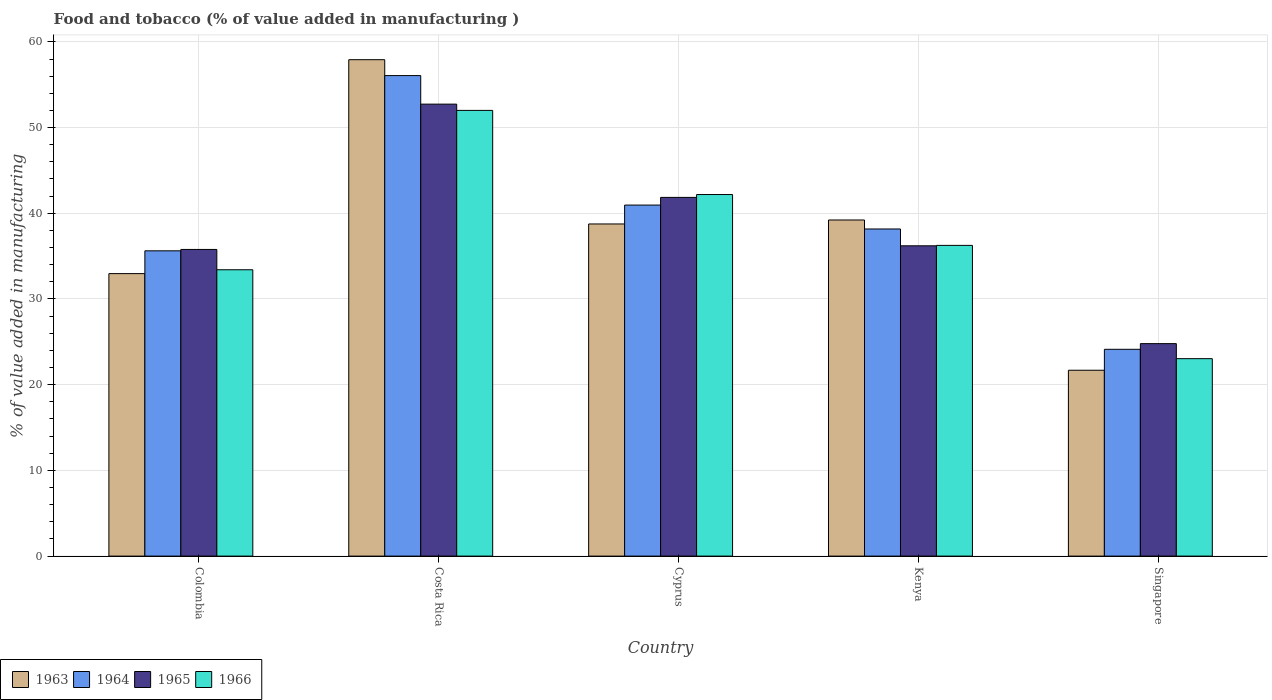How many different coloured bars are there?
Ensure brevity in your answer.  4. Are the number of bars per tick equal to the number of legend labels?
Your answer should be very brief. Yes. How many bars are there on the 5th tick from the left?
Your response must be concise. 4. How many bars are there on the 1st tick from the right?
Offer a terse response. 4. What is the label of the 3rd group of bars from the left?
Offer a terse response. Cyprus. What is the value added in manufacturing food and tobacco in 1963 in Singapore?
Provide a short and direct response. 21.69. Across all countries, what is the maximum value added in manufacturing food and tobacco in 1965?
Your response must be concise. 52.73. Across all countries, what is the minimum value added in manufacturing food and tobacco in 1964?
Your response must be concise. 24.13. In which country was the value added in manufacturing food and tobacco in 1963 maximum?
Ensure brevity in your answer.  Costa Rica. In which country was the value added in manufacturing food and tobacco in 1966 minimum?
Keep it short and to the point. Singapore. What is the total value added in manufacturing food and tobacco in 1965 in the graph?
Your answer should be very brief. 191.36. What is the difference between the value added in manufacturing food and tobacco in 1964 in Kenya and that in Singapore?
Your response must be concise. 14.04. What is the difference between the value added in manufacturing food and tobacco in 1963 in Singapore and the value added in manufacturing food and tobacco in 1966 in Costa Rica?
Provide a succinct answer. -30.32. What is the average value added in manufacturing food and tobacco in 1963 per country?
Ensure brevity in your answer.  38.11. What is the difference between the value added in manufacturing food and tobacco of/in 1965 and value added in manufacturing food and tobacco of/in 1963 in Colombia?
Offer a very short reply. 2.82. In how many countries, is the value added in manufacturing food and tobacco in 1964 greater than 48 %?
Offer a very short reply. 1. What is the ratio of the value added in manufacturing food and tobacco in 1965 in Cyprus to that in Kenya?
Offer a terse response. 1.16. What is the difference between the highest and the second highest value added in manufacturing food and tobacco in 1966?
Provide a short and direct response. -9.82. What is the difference between the highest and the lowest value added in manufacturing food and tobacco in 1964?
Offer a very short reply. 31.94. Is the sum of the value added in manufacturing food and tobacco in 1965 in Costa Rica and Singapore greater than the maximum value added in manufacturing food and tobacco in 1964 across all countries?
Keep it short and to the point. Yes. What does the 2nd bar from the left in Kenya represents?
Keep it short and to the point. 1964. What does the 1st bar from the right in Cyprus represents?
Offer a very short reply. 1966. How many bars are there?
Provide a succinct answer. 20. Are all the bars in the graph horizontal?
Offer a terse response. No. How many countries are there in the graph?
Make the answer very short. 5. Are the values on the major ticks of Y-axis written in scientific E-notation?
Provide a short and direct response. No. Does the graph contain any zero values?
Keep it short and to the point. No. Does the graph contain grids?
Your answer should be compact. Yes. How many legend labels are there?
Keep it short and to the point. 4. How are the legend labels stacked?
Make the answer very short. Horizontal. What is the title of the graph?
Provide a succinct answer. Food and tobacco (% of value added in manufacturing ). What is the label or title of the Y-axis?
Your answer should be very brief. % of value added in manufacturing. What is the % of value added in manufacturing of 1963 in Colombia?
Keep it short and to the point. 32.96. What is the % of value added in manufacturing of 1964 in Colombia?
Offer a very short reply. 35.62. What is the % of value added in manufacturing in 1965 in Colombia?
Offer a very short reply. 35.78. What is the % of value added in manufacturing of 1966 in Colombia?
Provide a short and direct response. 33.41. What is the % of value added in manufacturing of 1963 in Costa Rica?
Your answer should be compact. 57.92. What is the % of value added in manufacturing of 1964 in Costa Rica?
Your answer should be compact. 56.07. What is the % of value added in manufacturing in 1965 in Costa Rica?
Provide a succinct answer. 52.73. What is the % of value added in manufacturing of 1966 in Costa Rica?
Make the answer very short. 52. What is the % of value added in manufacturing of 1963 in Cyprus?
Give a very brief answer. 38.75. What is the % of value added in manufacturing of 1964 in Cyprus?
Your answer should be compact. 40.96. What is the % of value added in manufacturing in 1965 in Cyprus?
Keep it short and to the point. 41.85. What is the % of value added in manufacturing in 1966 in Cyprus?
Keep it short and to the point. 42.19. What is the % of value added in manufacturing of 1963 in Kenya?
Your response must be concise. 39.22. What is the % of value added in manufacturing of 1964 in Kenya?
Your answer should be compact. 38.17. What is the % of value added in manufacturing in 1965 in Kenya?
Offer a very short reply. 36.2. What is the % of value added in manufacturing in 1966 in Kenya?
Your response must be concise. 36.25. What is the % of value added in manufacturing of 1963 in Singapore?
Your answer should be compact. 21.69. What is the % of value added in manufacturing in 1964 in Singapore?
Keep it short and to the point. 24.13. What is the % of value added in manufacturing in 1965 in Singapore?
Offer a very short reply. 24.79. What is the % of value added in manufacturing of 1966 in Singapore?
Give a very brief answer. 23.04. Across all countries, what is the maximum % of value added in manufacturing of 1963?
Keep it short and to the point. 57.92. Across all countries, what is the maximum % of value added in manufacturing in 1964?
Provide a succinct answer. 56.07. Across all countries, what is the maximum % of value added in manufacturing in 1965?
Provide a short and direct response. 52.73. Across all countries, what is the maximum % of value added in manufacturing in 1966?
Give a very brief answer. 52. Across all countries, what is the minimum % of value added in manufacturing in 1963?
Keep it short and to the point. 21.69. Across all countries, what is the minimum % of value added in manufacturing in 1964?
Your response must be concise. 24.13. Across all countries, what is the minimum % of value added in manufacturing in 1965?
Make the answer very short. 24.79. Across all countries, what is the minimum % of value added in manufacturing in 1966?
Provide a succinct answer. 23.04. What is the total % of value added in manufacturing of 1963 in the graph?
Keep it short and to the point. 190.54. What is the total % of value added in manufacturing of 1964 in the graph?
Your response must be concise. 194.94. What is the total % of value added in manufacturing in 1965 in the graph?
Your response must be concise. 191.36. What is the total % of value added in manufacturing in 1966 in the graph?
Make the answer very short. 186.89. What is the difference between the % of value added in manufacturing of 1963 in Colombia and that in Costa Rica?
Offer a terse response. -24.96. What is the difference between the % of value added in manufacturing in 1964 in Colombia and that in Costa Rica?
Provide a succinct answer. -20.45. What is the difference between the % of value added in manufacturing in 1965 in Colombia and that in Costa Rica?
Keep it short and to the point. -16.95. What is the difference between the % of value added in manufacturing in 1966 in Colombia and that in Costa Rica?
Keep it short and to the point. -18.59. What is the difference between the % of value added in manufacturing in 1963 in Colombia and that in Cyprus?
Keep it short and to the point. -5.79. What is the difference between the % of value added in manufacturing in 1964 in Colombia and that in Cyprus?
Offer a very short reply. -5.34. What is the difference between the % of value added in manufacturing in 1965 in Colombia and that in Cyprus?
Give a very brief answer. -6.07. What is the difference between the % of value added in manufacturing in 1966 in Colombia and that in Cyprus?
Make the answer very short. -8.78. What is the difference between the % of value added in manufacturing of 1963 in Colombia and that in Kenya?
Provide a succinct answer. -6.26. What is the difference between the % of value added in manufacturing of 1964 in Colombia and that in Kenya?
Provide a succinct answer. -2.55. What is the difference between the % of value added in manufacturing of 1965 in Colombia and that in Kenya?
Ensure brevity in your answer.  -0.42. What is the difference between the % of value added in manufacturing in 1966 in Colombia and that in Kenya?
Your answer should be compact. -2.84. What is the difference between the % of value added in manufacturing of 1963 in Colombia and that in Singapore?
Make the answer very short. 11.27. What is the difference between the % of value added in manufacturing of 1964 in Colombia and that in Singapore?
Provide a succinct answer. 11.49. What is the difference between the % of value added in manufacturing of 1965 in Colombia and that in Singapore?
Ensure brevity in your answer.  10.99. What is the difference between the % of value added in manufacturing in 1966 in Colombia and that in Singapore?
Give a very brief answer. 10.37. What is the difference between the % of value added in manufacturing of 1963 in Costa Rica and that in Cyprus?
Offer a very short reply. 19.17. What is the difference between the % of value added in manufacturing in 1964 in Costa Rica and that in Cyprus?
Make the answer very short. 15.11. What is the difference between the % of value added in manufacturing of 1965 in Costa Rica and that in Cyprus?
Make the answer very short. 10.88. What is the difference between the % of value added in manufacturing in 1966 in Costa Rica and that in Cyprus?
Keep it short and to the point. 9.82. What is the difference between the % of value added in manufacturing in 1963 in Costa Rica and that in Kenya?
Your response must be concise. 18.7. What is the difference between the % of value added in manufacturing in 1964 in Costa Rica and that in Kenya?
Your response must be concise. 17.9. What is the difference between the % of value added in manufacturing of 1965 in Costa Rica and that in Kenya?
Your answer should be very brief. 16.53. What is the difference between the % of value added in manufacturing of 1966 in Costa Rica and that in Kenya?
Give a very brief answer. 15.75. What is the difference between the % of value added in manufacturing of 1963 in Costa Rica and that in Singapore?
Keep it short and to the point. 36.23. What is the difference between the % of value added in manufacturing of 1964 in Costa Rica and that in Singapore?
Provide a succinct answer. 31.94. What is the difference between the % of value added in manufacturing in 1965 in Costa Rica and that in Singapore?
Your response must be concise. 27.94. What is the difference between the % of value added in manufacturing in 1966 in Costa Rica and that in Singapore?
Make the answer very short. 28.97. What is the difference between the % of value added in manufacturing of 1963 in Cyprus and that in Kenya?
Your response must be concise. -0.46. What is the difference between the % of value added in manufacturing of 1964 in Cyprus and that in Kenya?
Offer a very short reply. 2.79. What is the difference between the % of value added in manufacturing of 1965 in Cyprus and that in Kenya?
Ensure brevity in your answer.  5.65. What is the difference between the % of value added in manufacturing in 1966 in Cyprus and that in Kenya?
Ensure brevity in your answer.  5.93. What is the difference between the % of value added in manufacturing in 1963 in Cyprus and that in Singapore?
Ensure brevity in your answer.  17.07. What is the difference between the % of value added in manufacturing of 1964 in Cyprus and that in Singapore?
Make the answer very short. 16.83. What is the difference between the % of value added in manufacturing in 1965 in Cyprus and that in Singapore?
Make the answer very short. 17.06. What is the difference between the % of value added in manufacturing of 1966 in Cyprus and that in Singapore?
Provide a succinct answer. 19.15. What is the difference between the % of value added in manufacturing in 1963 in Kenya and that in Singapore?
Offer a very short reply. 17.53. What is the difference between the % of value added in manufacturing in 1964 in Kenya and that in Singapore?
Offer a terse response. 14.04. What is the difference between the % of value added in manufacturing of 1965 in Kenya and that in Singapore?
Your answer should be very brief. 11.41. What is the difference between the % of value added in manufacturing of 1966 in Kenya and that in Singapore?
Keep it short and to the point. 13.22. What is the difference between the % of value added in manufacturing in 1963 in Colombia and the % of value added in manufacturing in 1964 in Costa Rica?
Offer a terse response. -23.11. What is the difference between the % of value added in manufacturing in 1963 in Colombia and the % of value added in manufacturing in 1965 in Costa Rica?
Provide a short and direct response. -19.77. What is the difference between the % of value added in manufacturing in 1963 in Colombia and the % of value added in manufacturing in 1966 in Costa Rica?
Give a very brief answer. -19.04. What is the difference between the % of value added in manufacturing of 1964 in Colombia and the % of value added in manufacturing of 1965 in Costa Rica?
Offer a terse response. -17.11. What is the difference between the % of value added in manufacturing of 1964 in Colombia and the % of value added in manufacturing of 1966 in Costa Rica?
Keep it short and to the point. -16.38. What is the difference between the % of value added in manufacturing of 1965 in Colombia and the % of value added in manufacturing of 1966 in Costa Rica?
Ensure brevity in your answer.  -16.22. What is the difference between the % of value added in manufacturing of 1963 in Colombia and the % of value added in manufacturing of 1964 in Cyprus?
Give a very brief answer. -8. What is the difference between the % of value added in manufacturing in 1963 in Colombia and the % of value added in manufacturing in 1965 in Cyprus?
Your answer should be compact. -8.89. What is the difference between the % of value added in manufacturing of 1963 in Colombia and the % of value added in manufacturing of 1966 in Cyprus?
Offer a terse response. -9.23. What is the difference between the % of value added in manufacturing of 1964 in Colombia and the % of value added in manufacturing of 1965 in Cyprus?
Your answer should be compact. -6.23. What is the difference between the % of value added in manufacturing in 1964 in Colombia and the % of value added in manufacturing in 1966 in Cyprus?
Your response must be concise. -6.57. What is the difference between the % of value added in manufacturing of 1965 in Colombia and the % of value added in manufacturing of 1966 in Cyprus?
Offer a very short reply. -6.41. What is the difference between the % of value added in manufacturing in 1963 in Colombia and the % of value added in manufacturing in 1964 in Kenya?
Give a very brief answer. -5.21. What is the difference between the % of value added in manufacturing in 1963 in Colombia and the % of value added in manufacturing in 1965 in Kenya?
Your answer should be very brief. -3.24. What is the difference between the % of value added in manufacturing in 1963 in Colombia and the % of value added in manufacturing in 1966 in Kenya?
Ensure brevity in your answer.  -3.29. What is the difference between the % of value added in manufacturing in 1964 in Colombia and the % of value added in manufacturing in 1965 in Kenya?
Your answer should be very brief. -0.58. What is the difference between the % of value added in manufacturing in 1964 in Colombia and the % of value added in manufacturing in 1966 in Kenya?
Ensure brevity in your answer.  -0.63. What is the difference between the % of value added in manufacturing of 1965 in Colombia and the % of value added in manufacturing of 1966 in Kenya?
Give a very brief answer. -0.47. What is the difference between the % of value added in manufacturing in 1963 in Colombia and the % of value added in manufacturing in 1964 in Singapore?
Offer a terse response. 8.83. What is the difference between the % of value added in manufacturing of 1963 in Colombia and the % of value added in manufacturing of 1965 in Singapore?
Offer a terse response. 8.17. What is the difference between the % of value added in manufacturing of 1963 in Colombia and the % of value added in manufacturing of 1966 in Singapore?
Provide a succinct answer. 9.92. What is the difference between the % of value added in manufacturing in 1964 in Colombia and the % of value added in manufacturing in 1965 in Singapore?
Offer a terse response. 10.83. What is the difference between the % of value added in manufacturing of 1964 in Colombia and the % of value added in manufacturing of 1966 in Singapore?
Provide a succinct answer. 12.58. What is the difference between the % of value added in manufacturing of 1965 in Colombia and the % of value added in manufacturing of 1966 in Singapore?
Give a very brief answer. 12.74. What is the difference between the % of value added in manufacturing in 1963 in Costa Rica and the % of value added in manufacturing in 1964 in Cyprus?
Provide a short and direct response. 16.96. What is the difference between the % of value added in manufacturing in 1963 in Costa Rica and the % of value added in manufacturing in 1965 in Cyprus?
Your answer should be compact. 16.07. What is the difference between the % of value added in manufacturing in 1963 in Costa Rica and the % of value added in manufacturing in 1966 in Cyprus?
Provide a short and direct response. 15.73. What is the difference between the % of value added in manufacturing of 1964 in Costa Rica and the % of value added in manufacturing of 1965 in Cyprus?
Provide a succinct answer. 14.21. What is the difference between the % of value added in manufacturing in 1964 in Costa Rica and the % of value added in manufacturing in 1966 in Cyprus?
Ensure brevity in your answer.  13.88. What is the difference between the % of value added in manufacturing in 1965 in Costa Rica and the % of value added in manufacturing in 1966 in Cyprus?
Keep it short and to the point. 10.55. What is the difference between the % of value added in manufacturing in 1963 in Costa Rica and the % of value added in manufacturing in 1964 in Kenya?
Provide a succinct answer. 19.75. What is the difference between the % of value added in manufacturing of 1963 in Costa Rica and the % of value added in manufacturing of 1965 in Kenya?
Make the answer very short. 21.72. What is the difference between the % of value added in manufacturing of 1963 in Costa Rica and the % of value added in manufacturing of 1966 in Kenya?
Your response must be concise. 21.67. What is the difference between the % of value added in manufacturing in 1964 in Costa Rica and the % of value added in manufacturing in 1965 in Kenya?
Keep it short and to the point. 19.86. What is the difference between the % of value added in manufacturing in 1964 in Costa Rica and the % of value added in manufacturing in 1966 in Kenya?
Make the answer very short. 19.81. What is the difference between the % of value added in manufacturing in 1965 in Costa Rica and the % of value added in manufacturing in 1966 in Kenya?
Provide a succinct answer. 16.48. What is the difference between the % of value added in manufacturing of 1963 in Costa Rica and the % of value added in manufacturing of 1964 in Singapore?
Your answer should be compact. 33.79. What is the difference between the % of value added in manufacturing in 1963 in Costa Rica and the % of value added in manufacturing in 1965 in Singapore?
Keep it short and to the point. 33.13. What is the difference between the % of value added in manufacturing in 1963 in Costa Rica and the % of value added in manufacturing in 1966 in Singapore?
Your response must be concise. 34.88. What is the difference between the % of value added in manufacturing of 1964 in Costa Rica and the % of value added in manufacturing of 1965 in Singapore?
Provide a succinct answer. 31.28. What is the difference between the % of value added in manufacturing of 1964 in Costa Rica and the % of value added in manufacturing of 1966 in Singapore?
Your answer should be very brief. 33.03. What is the difference between the % of value added in manufacturing in 1965 in Costa Rica and the % of value added in manufacturing in 1966 in Singapore?
Offer a terse response. 29.7. What is the difference between the % of value added in manufacturing in 1963 in Cyprus and the % of value added in manufacturing in 1964 in Kenya?
Your answer should be compact. 0.59. What is the difference between the % of value added in manufacturing in 1963 in Cyprus and the % of value added in manufacturing in 1965 in Kenya?
Your answer should be very brief. 2.55. What is the difference between the % of value added in manufacturing of 1963 in Cyprus and the % of value added in manufacturing of 1966 in Kenya?
Provide a succinct answer. 2.5. What is the difference between the % of value added in manufacturing in 1964 in Cyprus and the % of value added in manufacturing in 1965 in Kenya?
Ensure brevity in your answer.  4.75. What is the difference between the % of value added in manufacturing of 1964 in Cyprus and the % of value added in manufacturing of 1966 in Kenya?
Your response must be concise. 4.7. What is the difference between the % of value added in manufacturing of 1965 in Cyprus and the % of value added in manufacturing of 1966 in Kenya?
Keep it short and to the point. 5.6. What is the difference between the % of value added in manufacturing in 1963 in Cyprus and the % of value added in manufacturing in 1964 in Singapore?
Keep it short and to the point. 14.63. What is the difference between the % of value added in manufacturing in 1963 in Cyprus and the % of value added in manufacturing in 1965 in Singapore?
Provide a short and direct response. 13.96. What is the difference between the % of value added in manufacturing in 1963 in Cyprus and the % of value added in manufacturing in 1966 in Singapore?
Give a very brief answer. 15.72. What is the difference between the % of value added in manufacturing in 1964 in Cyprus and the % of value added in manufacturing in 1965 in Singapore?
Provide a succinct answer. 16.17. What is the difference between the % of value added in manufacturing in 1964 in Cyprus and the % of value added in manufacturing in 1966 in Singapore?
Offer a very short reply. 17.92. What is the difference between the % of value added in manufacturing of 1965 in Cyprus and the % of value added in manufacturing of 1966 in Singapore?
Ensure brevity in your answer.  18.82. What is the difference between the % of value added in manufacturing in 1963 in Kenya and the % of value added in manufacturing in 1964 in Singapore?
Provide a short and direct response. 15.09. What is the difference between the % of value added in manufacturing in 1963 in Kenya and the % of value added in manufacturing in 1965 in Singapore?
Your answer should be compact. 14.43. What is the difference between the % of value added in manufacturing in 1963 in Kenya and the % of value added in manufacturing in 1966 in Singapore?
Make the answer very short. 16.18. What is the difference between the % of value added in manufacturing in 1964 in Kenya and the % of value added in manufacturing in 1965 in Singapore?
Provide a succinct answer. 13.38. What is the difference between the % of value added in manufacturing of 1964 in Kenya and the % of value added in manufacturing of 1966 in Singapore?
Ensure brevity in your answer.  15.13. What is the difference between the % of value added in manufacturing in 1965 in Kenya and the % of value added in manufacturing in 1966 in Singapore?
Your answer should be compact. 13.17. What is the average % of value added in manufacturing in 1963 per country?
Ensure brevity in your answer.  38.11. What is the average % of value added in manufacturing of 1964 per country?
Your answer should be very brief. 38.99. What is the average % of value added in manufacturing in 1965 per country?
Make the answer very short. 38.27. What is the average % of value added in manufacturing in 1966 per country?
Your answer should be very brief. 37.38. What is the difference between the % of value added in manufacturing of 1963 and % of value added in manufacturing of 1964 in Colombia?
Provide a short and direct response. -2.66. What is the difference between the % of value added in manufacturing in 1963 and % of value added in manufacturing in 1965 in Colombia?
Make the answer very short. -2.82. What is the difference between the % of value added in manufacturing of 1963 and % of value added in manufacturing of 1966 in Colombia?
Provide a succinct answer. -0.45. What is the difference between the % of value added in manufacturing in 1964 and % of value added in manufacturing in 1965 in Colombia?
Provide a short and direct response. -0.16. What is the difference between the % of value added in manufacturing in 1964 and % of value added in manufacturing in 1966 in Colombia?
Ensure brevity in your answer.  2.21. What is the difference between the % of value added in manufacturing in 1965 and % of value added in manufacturing in 1966 in Colombia?
Your answer should be compact. 2.37. What is the difference between the % of value added in manufacturing in 1963 and % of value added in manufacturing in 1964 in Costa Rica?
Ensure brevity in your answer.  1.85. What is the difference between the % of value added in manufacturing of 1963 and % of value added in manufacturing of 1965 in Costa Rica?
Your answer should be very brief. 5.19. What is the difference between the % of value added in manufacturing in 1963 and % of value added in manufacturing in 1966 in Costa Rica?
Offer a very short reply. 5.92. What is the difference between the % of value added in manufacturing in 1964 and % of value added in manufacturing in 1965 in Costa Rica?
Make the answer very short. 3.33. What is the difference between the % of value added in manufacturing in 1964 and % of value added in manufacturing in 1966 in Costa Rica?
Your answer should be compact. 4.06. What is the difference between the % of value added in manufacturing in 1965 and % of value added in manufacturing in 1966 in Costa Rica?
Provide a succinct answer. 0.73. What is the difference between the % of value added in manufacturing of 1963 and % of value added in manufacturing of 1964 in Cyprus?
Offer a very short reply. -2.2. What is the difference between the % of value added in manufacturing of 1963 and % of value added in manufacturing of 1965 in Cyprus?
Your answer should be compact. -3.1. What is the difference between the % of value added in manufacturing of 1963 and % of value added in manufacturing of 1966 in Cyprus?
Provide a succinct answer. -3.43. What is the difference between the % of value added in manufacturing of 1964 and % of value added in manufacturing of 1965 in Cyprus?
Provide a short and direct response. -0.9. What is the difference between the % of value added in manufacturing in 1964 and % of value added in manufacturing in 1966 in Cyprus?
Provide a succinct answer. -1.23. What is the difference between the % of value added in manufacturing in 1963 and % of value added in manufacturing in 1964 in Kenya?
Offer a terse response. 1.05. What is the difference between the % of value added in manufacturing of 1963 and % of value added in manufacturing of 1965 in Kenya?
Provide a short and direct response. 3.01. What is the difference between the % of value added in manufacturing of 1963 and % of value added in manufacturing of 1966 in Kenya?
Provide a succinct answer. 2.96. What is the difference between the % of value added in manufacturing of 1964 and % of value added in manufacturing of 1965 in Kenya?
Make the answer very short. 1.96. What is the difference between the % of value added in manufacturing in 1964 and % of value added in manufacturing in 1966 in Kenya?
Give a very brief answer. 1.91. What is the difference between the % of value added in manufacturing in 1963 and % of value added in manufacturing in 1964 in Singapore?
Your response must be concise. -2.44. What is the difference between the % of value added in manufacturing in 1963 and % of value added in manufacturing in 1965 in Singapore?
Your answer should be compact. -3.1. What is the difference between the % of value added in manufacturing of 1963 and % of value added in manufacturing of 1966 in Singapore?
Offer a very short reply. -1.35. What is the difference between the % of value added in manufacturing of 1964 and % of value added in manufacturing of 1965 in Singapore?
Your answer should be very brief. -0.66. What is the difference between the % of value added in manufacturing in 1964 and % of value added in manufacturing in 1966 in Singapore?
Your answer should be very brief. 1.09. What is the difference between the % of value added in manufacturing in 1965 and % of value added in manufacturing in 1966 in Singapore?
Make the answer very short. 1.75. What is the ratio of the % of value added in manufacturing in 1963 in Colombia to that in Costa Rica?
Keep it short and to the point. 0.57. What is the ratio of the % of value added in manufacturing of 1964 in Colombia to that in Costa Rica?
Offer a terse response. 0.64. What is the ratio of the % of value added in manufacturing of 1965 in Colombia to that in Costa Rica?
Your answer should be very brief. 0.68. What is the ratio of the % of value added in manufacturing in 1966 in Colombia to that in Costa Rica?
Provide a short and direct response. 0.64. What is the ratio of the % of value added in manufacturing in 1963 in Colombia to that in Cyprus?
Ensure brevity in your answer.  0.85. What is the ratio of the % of value added in manufacturing in 1964 in Colombia to that in Cyprus?
Keep it short and to the point. 0.87. What is the ratio of the % of value added in manufacturing of 1965 in Colombia to that in Cyprus?
Give a very brief answer. 0.85. What is the ratio of the % of value added in manufacturing of 1966 in Colombia to that in Cyprus?
Make the answer very short. 0.79. What is the ratio of the % of value added in manufacturing in 1963 in Colombia to that in Kenya?
Provide a short and direct response. 0.84. What is the ratio of the % of value added in manufacturing of 1964 in Colombia to that in Kenya?
Your answer should be compact. 0.93. What is the ratio of the % of value added in manufacturing in 1965 in Colombia to that in Kenya?
Your response must be concise. 0.99. What is the ratio of the % of value added in manufacturing of 1966 in Colombia to that in Kenya?
Your answer should be compact. 0.92. What is the ratio of the % of value added in manufacturing of 1963 in Colombia to that in Singapore?
Give a very brief answer. 1.52. What is the ratio of the % of value added in manufacturing of 1964 in Colombia to that in Singapore?
Keep it short and to the point. 1.48. What is the ratio of the % of value added in manufacturing in 1965 in Colombia to that in Singapore?
Give a very brief answer. 1.44. What is the ratio of the % of value added in manufacturing of 1966 in Colombia to that in Singapore?
Your response must be concise. 1.45. What is the ratio of the % of value added in manufacturing of 1963 in Costa Rica to that in Cyprus?
Ensure brevity in your answer.  1.49. What is the ratio of the % of value added in manufacturing of 1964 in Costa Rica to that in Cyprus?
Make the answer very short. 1.37. What is the ratio of the % of value added in manufacturing of 1965 in Costa Rica to that in Cyprus?
Keep it short and to the point. 1.26. What is the ratio of the % of value added in manufacturing in 1966 in Costa Rica to that in Cyprus?
Offer a terse response. 1.23. What is the ratio of the % of value added in manufacturing in 1963 in Costa Rica to that in Kenya?
Ensure brevity in your answer.  1.48. What is the ratio of the % of value added in manufacturing in 1964 in Costa Rica to that in Kenya?
Provide a short and direct response. 1.47. What is the ratio of the % of value added in manufacturing of 1965 in Costa Rica to that in Kenya?
Give a very brief answer. 1.46. What is the ratio of the % of value added in manufacturing in 1966 in Costa Rica to that in Kenya?
Give a very brief answer. 1.43. What is the ratio of the % of value added in manufacturing in 1963 in Costa Rica to that in Singapore?
Your response must be concise. 2.67. What is the ratio of the % of value added in manufacturing in 1964 in Costa Rica to that in Singapore?
Provide a succinct answer. 2.32. What is the ratio of the % of value added in manufacturing of 1965 in Costa Rica to that in Singapore?
Your answer should be compact. 2.13. What is the ratio of the % of value added in manufacturing of 1966 in Costa Rica to that in Singapore?
Keep it short and to the point. 2.26. What is the ratio of the % of value added in manufacturing in 1963 in Cyprus to that in Kenya?
Provide a short and direct response. 0.99. What is the ratio of the % of value added in manufacturing of 1964 in Cyprus to that in Kenya?
Offer a very short reply. 1.07. What is the ratio of the % of value added in manufacturing of 1965 in Cyprus to that in Kenya?
Offer a terse response. 1.16. What is the ratio of the % of value added in manufacturing of 1966 in Cyprus to that in Kenya?
Provide a short and direct response. 1.16. What is the ratio of the % of value added in manufacturing in 1963 in Cyprus to that in Singapore?
Offer a very short reply. 1.79. What is the ratio of the % of value added in manufacturing of 1964 in Cyprus to that in Singapore?
Provide a succinct answer. 1.7. What is the ratio of the % of value added in manufacturing of 1965 in Cyprus to that in Singapore?
Your response must be concise. 1.69. What is the ratio of the % of value added in manufacturing of 1966 in Cyprus to that in Singapore?
Provide a succinct answer. 1.83. What is the ratio of the % of value added in manufacturing of 1963 in Kenya to that in Singapore?
Keep it short and to the point. 1.81. What is the ratio of the % of value added in manufacturing of 1964 in Kenya to that in Singapore?
Give a very brief answer. 1.58. What is the ratio of the % of value added in manufacturing of 1965 in Kenya to that in Singapore?
Provide a short and direct response. 1.46. What is the ratio of the % of value added in manufacturing in 1966 in Kenya to that in Singapore?
Your answer should be very brief. 1.57. What is the difference between the highest and the second highest % of value added in manufacturing in 1963?
Keep it short and to the point. 18.7. What is the difference between the highest and the second highest % of value added in manufacturing of 1964?
Make the answer very short. 15.11. What is the difference between the highest and the second highest % of value added in manufacturing of 1965?
Your answer should be very brief. 10.88. What is the difference between the highest and the second highest % of value added in manufacturing in 1966?
Provide a short and direct response. 9.82. What is the difference between the highest and the lowest % of value added in manufacturing in 1963?
Provide a short and direct response. 36.23. What is the difference between the highest and the lowest % of value added in manufacturing of 1964?
Give a very brief answer. 31.94. What is the difference between the highest and the lowest % of value added in manufacturing in 1965?
Make the answer very short. 27.94. What is the difference between the highest and the lowest % of value added in manufacturing in 1966?
Give a very brief answer. 28.97. 